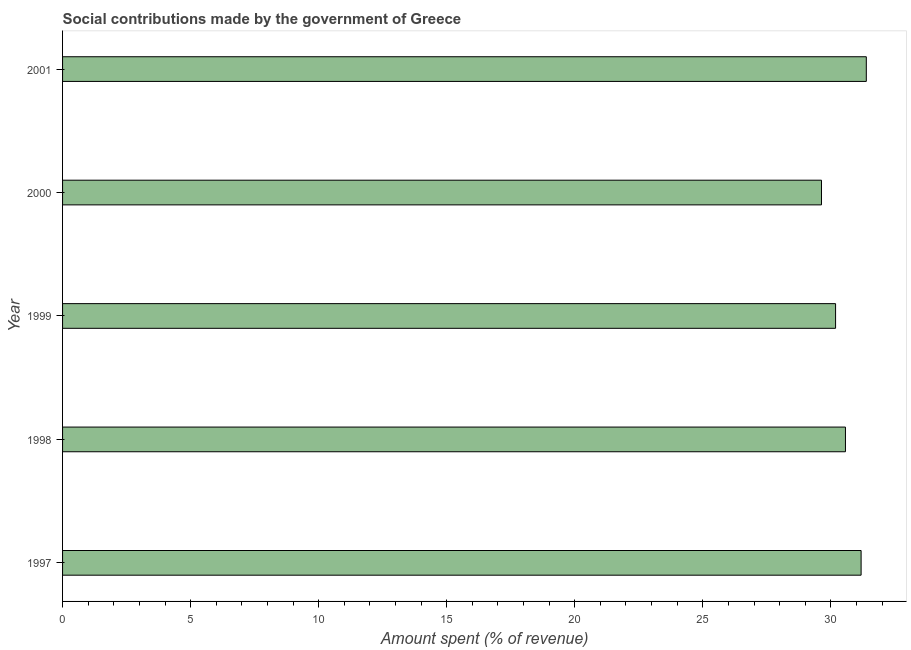Does the graph contain grids?
Give a very brief answer. No. What is the title of the graph?
Your answer should be very brief. Social contributions made by the government of Greece. What is the label or title of the X-axis?
Ensure brevity in your answer.  Amount spent (% of revenue). What is the amount spent in making social contributions in 1998?
Give a very brief answer. 30.57. Across all years, what is the maximum amount spent in making social contributions?
Provide a succinct answer. 31.38. Across all years, what is the minimum amount spent in making social contributions?
Your answer should be compact. 29.63. What is the sum of the amount spent in making social contributions?
Keep it short and to the point. 152.95. What is the difference between the amount spent in making social contributions in 1998 and 2000?
Provide a succinct answer. 0.94. What is the average amount spent in making social contributions per year?
Your response must be concise. 30.59. What is the median amount spent in making social contributions?
Ensure brevity in your answer.  30.57. What is the ratio of the amount spent in making social contributions in 1997 to that in 2001?
Provide a succinct answer. 0.99. What is the difference between the highest and the second highest amount spent in making social contributions?
Your answer should be compact. 0.2. How many bars are there?
Offer a very short reply. 5. Are the values on the major ticks of X-axis written in scientific E-notation?
Your answer should be very brief. No. What is the Amount spent (% of revenue) of 1997?
Your answer should be very brief. 31.18. What is the Amount spent (% of revenue) in 1998?
Keep it short and to the point. 30.57. What is the Amount spent (% of revenue) in 1999?
Ensure brevity in your answer.  30.18. What is the Amount spent (% of revenue) of 2000?
Provide a succinct answer. 29.63. What is the Amount spent (% of revenue) in 2001?
Keep it short and to the point. 31.38. What is the difference between the Amount spent (% of revenue) in 1997 and 1998?
Your answer should be compact. 0.61. What is the difference between the Amount spent (% of revenue) in 1997 and 1999?
Your answer should be compact. 1. What is the difference between the Amount spent (% of revenue) in 1997 and 2000?
Ensure brevity in your answer.  1.55. What is the difference between the Amount spent (% of revenue) in 1997 and 2001?
Give a very brief answer. -0.2. What is the difference between the Amount spent (% of revenue) in 1998 and 1999?
Your answer should be very brief. 0.39. What is the difference between the Amount spent (% of revenue) in 1998 and 2000?
Offer a very short reply. 0.94. What is the difference between the Amount spent (% of revenue) in 1998 and 2001?
Provide a succinct answer. -0.81. What is the difference between the Amount spent (% of revenue) in 1999 and 2000?
Make the answer very short. 0.55. What is the difference between the Amount spent (% of revenue) in 1999 and 2001?
Provide a short and direct response. -1.2. What is the difference between the Amount spent (% of revenue) in 2000 and 2001?
Make the answer very short. -1.75. What is the ratio of the Amount spent (% of revenue) in 1997 to that in 1998?
Your answer should be compact. 1.02. What is the ratio of the Amount spent (% of revenue) in 1997 to that in 1999?
Make the answer very short. 1.03. What is the ratio of the Amount spent (% of revenue) in 1997 to that in 2000?
Keep it short and to the point. 1.05. What is the ratio of the Amount spent (% of revenue) in 1997 to that in 2001?
Offer a terse response. 0.99. What is the ratio of the Amount spent (% of revenue) in 1998 to that in 2000?
Your response must be concise. 1.03. What is the ratio of the Amount spent (% of revenue) in 1998 to that in 2001?
Your answer should be compact. 0.97. What is the ratio of the Amount spent (% of revenue) in 1999 to that in 2000?
Offer a terse response. 1.02. What is the ratio of the Amount spent (% of revenue) in 2000 to that in 2001?
Provide a succinct answer. 0.94. 